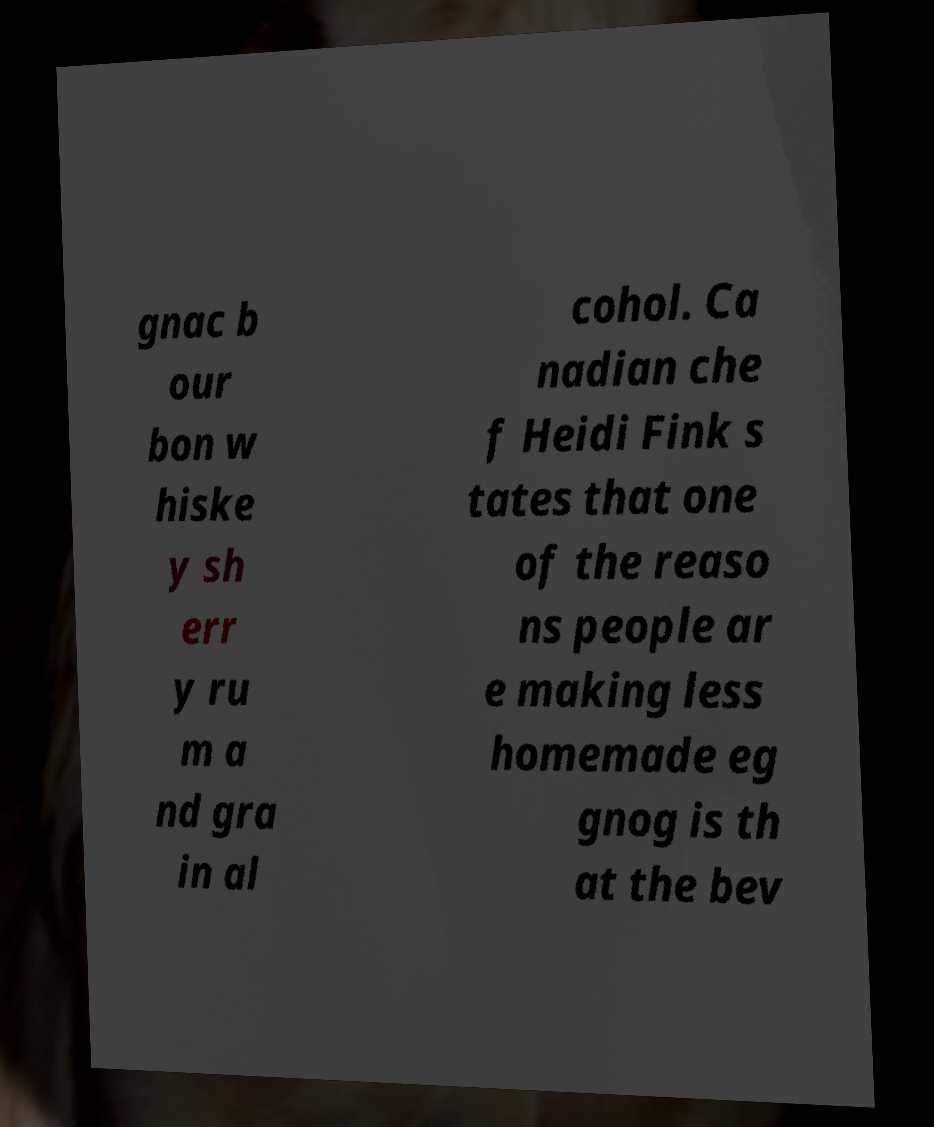There's text embedded in this image that I need extracted. Can you transcribe it verbatim? gnac b our bon w hiske y sh err y ru m a nd gra in al cohol. Ca nadian che f Heidi Fink s tates that one of the reaso ns people ar e making less homemade eg gnog is th at the bev 